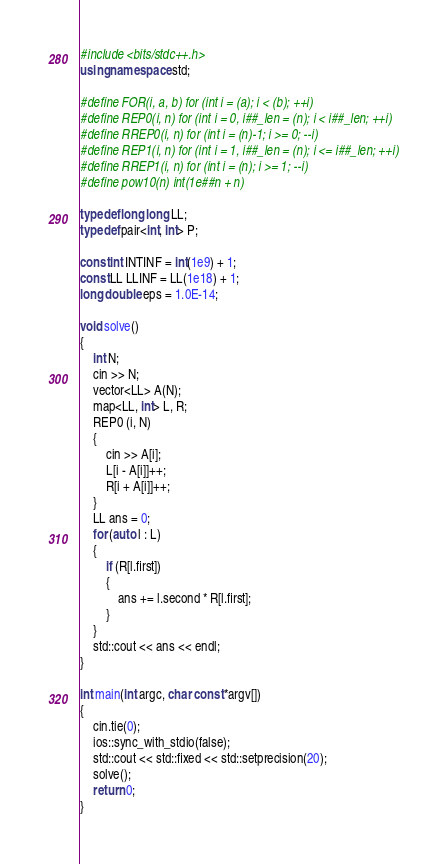Convert code to text. <code><loc_0><loc_0><loc_500><loc_500><_C++_>#include <bits/stdc++.h>
using namespace std;

#define FOR(i, a, b) for (int i = (a); i < (b); ++i)
#define REP0(i, n) for (int i = 0, i##_len = (n); i < i##_len; ++i)
#define RREP0(i, n) for (int i = (n)-1; i >= 0; --i)
#define REP1(i, n) for (int i = 1, i##_len = (n); i <= i##_len; ++i)
#define RREP1(i, n) for (int i = (n); i >= 1; --i)
#define pow10(n) int(1e##n + n)

typedef long long LL;
typedef pair<int, int> P;

const int INTINF = int(1e9) + 1;
const LL LLINF = LL(1e18) + 1;
long double eps = 1.0E-14;

void solve()
{
    int N;
    cin >> N;
    vector<LL> A(N);
    map<LL, int> L, R;
    REP0 (i, N)
    {
        cin >> A[i];
        L[i - A[i]]++;
        R[i + A[i]]++;
    }
    LL ans = 0;
    for (auto l : L)
    {
        if (R[l.first])
        {
            ans += l.second * R[l.first];
        }
    }
    std::cout << ans << endl;
}

int main(int argc, char const *argv[])
{
    cin.tie(0);
    ios::sync_with_stdio(false);
    std::cout << std::fixed << std::setprecision(20);
    solve();
    return 0;
}
</code> 